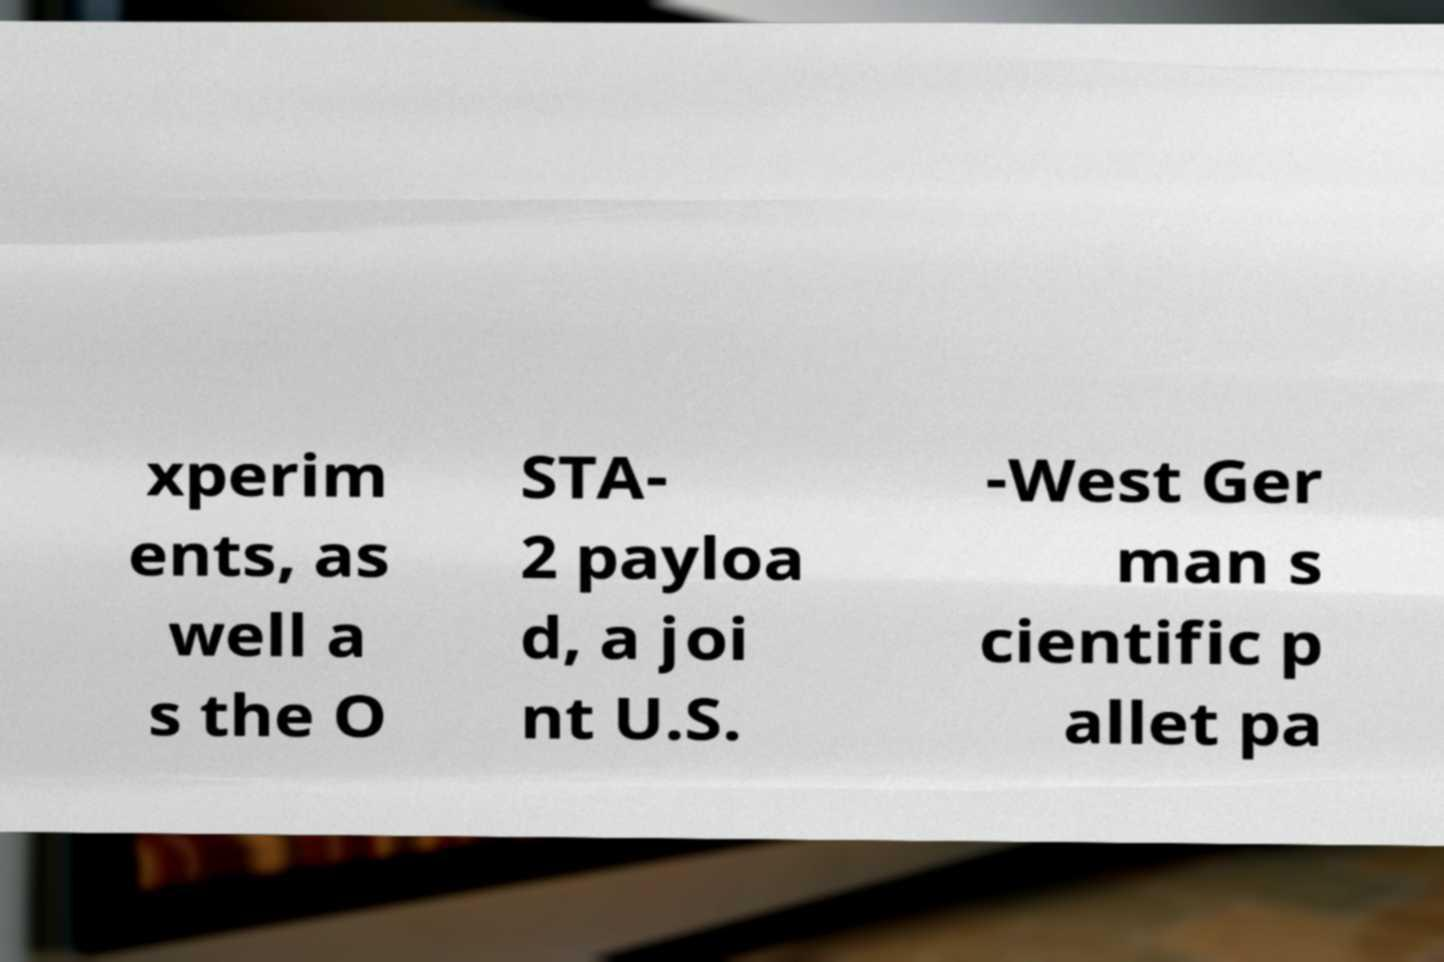What messages or text are displayed in this image? I need them in a readable, typed format. xperim ents, as well a s the O STA- 2 payloa d, a joi nt U.S. -West Ger man s cientific p allet pa 